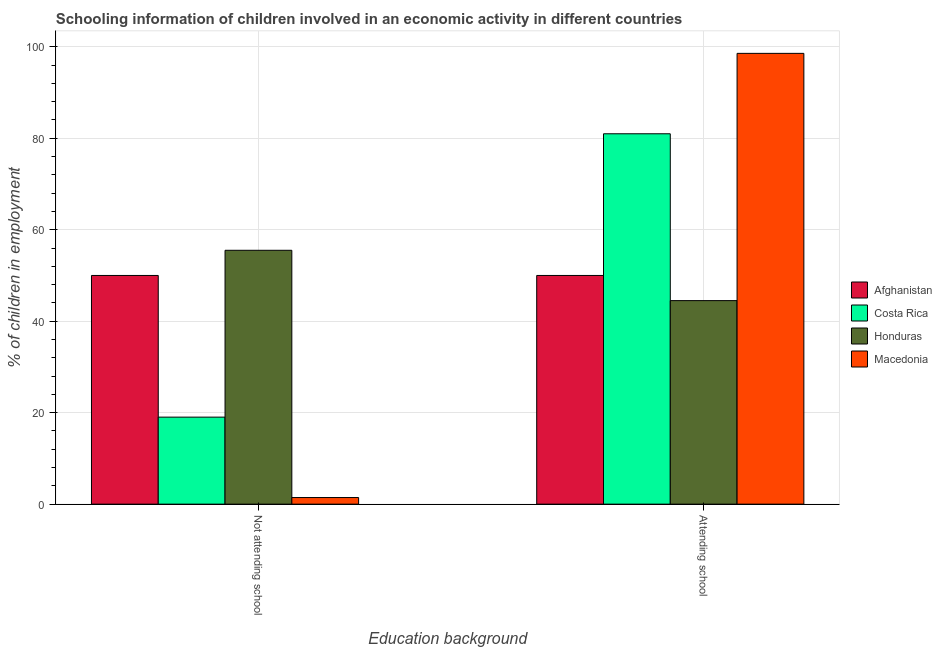How many groups of bars are there?
Ensure brevity in your answer.  2. Are the number of bars per tick equal to the number of legend labels?
Offer a very short reply. Yes. Are the number of bars on each tick of the X-axis equal?
Offer a terse response. Yes. How many bars are there on the 2nd tick from the left?
Provide a short and direct response. 4. What is the label of the 1st group of bars from the left?
Your answer should be very brief. Not attending school. What is the percentage of employed children who are attending school in Costa Rica?
Give a very brief answer. 80.98. Across all countries, what is the maximum percentage of employed children who are not attending school?
Make the answer very short. 55.5. Across all countries, what is the minimum percentage of employed children who are not attending school?
Provide a short and direct response. 1.45. In which country was the percentage of employed children who are not attending school maximum?
Your answer should be very brief. Honduras. In which country was the percentage of employed children who are attending school minimum?
Your answer should be compact. Honduras. What is the total percentage of employed children who are attending school in the graph?
Your answer should be compact. 274.03. What is the difference between the percentage of employed children who are attending school in Honduras and that in Macedonia?
Offer a very short reply. -54.05. What is the difference between the percentage of employed children who are not attending school in Macedonia and the percentage of employed children who are attending school in Costa Rica?
Ensure brevity in your answer.  -79.53. What is the average percentage of employed children who are not attending school per country?
Offer a terse response. 31.49. What is the difference between the percentage of employed children who are attending school and percentage of employed children who are not attending school in Macedonia?
Make the answer very short. 97.11. What is the ratio of the percentage of employed children who are not attending school in Honduras to that in Afghanistan?
Make the answer very short. 1.11. What does the 3rd bar from the left in Attending school represents?
Provide a succinct answer. Honduras. What does the 4th bar from the right in Not attending school represents?
Offer a terse response. Afghanistan. Are all the bars in the graph horizontal?
Make the answer very short. No. How many countries are there in the graph?
Your response must be concise. 4. Does the graph contain grids?
Provide a succinct answer. Yes. Where does the legend appear in the graph?
Your answer should be very brief. Center right. How are the legend labels stacked?
Your answer should be very brief. Vertical. What is the title of the graph?
Your answer should be compact. Schooling information of children involved in an economic activity in different countries. Does "Hong Kong" appear as one of the legend labels in the graph?
Provide a succinct answer. No. What is the label or title of the X-axis?
Provide a short and direct response. Education background. What is the label or title of the Y-axis?
Your answer should be very brief. % of children in employment. What is the % of children in employment of Afghanistan in Not attending school?
Offer a very short reply. 50. What is the % of children in employment of Costa Rica in Not attending school?
Give a very brief answer. 19.02. What is the % of children in employment in Honduras in Not attending school?
Keep it short and to the point. 55.5. What is the % of children in employment of Macedonia in Not attending school?
Your answer should be compact. 1.45. What is the % of children in employment of Afghanistan in Attending school?
Offer a very short reply. 50. What is the % of children in employment in Costa Rica in Attending school?
Provide a short and direct response. 80.98. What is the % of children in employment in Honduras in Attending school?
Offer a terse response. 44.5. What is the % of children in employment in Macedonia in Attending school?
Give a very brief answer. 98.55. Across all Education background, what is the maximum % of children in employment in Afghanistan?
Offer a very short reply. 50. Across all Education background, what is the maximum % of children in employment in Costa Rica?
Ensure brevity in your answer.  80.98. Across all Education background, what is the maximum % of children in employment of Honduras?
Provide a short and direct response. 55.5. Across all Education background, what is the maximum % of children in employment of Macedonia?
Provide a succinct answer. 98.55. Across all Education background, what is the minimum % of children in employment in Afghanistan?
Keep it short and to the point. 50. Across all Education background, what is the minimum % of children in employment in Costa Rica?
Offer a very short reply. 19.02. Across all Education background, what is the minimum % of children in employment in Honduras?
Provide a short and direct response. 44.5. Across all Education background, what is the minimum % of children in employment of Macedonia?
Your response must be concise. 1.45. What is the total % of children in employment in Costa Rica in the graph?
Offer a terse response. 100. What is the difference between the % of children in employment of Costa Rica in Not attending school and that in Attending school?
Keep it short and to the point. -61.95. What is the difference between the % of children in employment in Macedonia in Not attending school and that in Attending school?
Ensure brevity in your answer.  -97.11. What is the difference between the % of children in employment of Afghanistan in Not attending school and the % of children in employment of Costa Rica in Attending school?
Ensure brevity in your answer.  -30.98. What is the difference between the % of children in employment in Afghanistan in Not attending school and the % of children in employment in Honduras in Attending school?
Your answer should be compact. 5.5. What is the difference between the % of children in employment in Afghanistan in Not attending school and the % of children in employment in Macedonia in Attending school?
Provide a short and direct response. -48.55. What is the difference between the % of children in employment of Costa Rica in Not attending school and the % of children in employment of Honduras in Attending school?
Your answer should be very brief. -25.48. What is the difference between the % of children in employment of Costa Rica in Not attending school and the % of children in employment of Macedonia in Attending school?
Give a very brief answer. -79.53. What is the difference between the % of children in employment in Honduras in Not attending school and the % of children in employment in Macedonia in Attending school?
Offer a very short reply. -43.05. What is the average % of children in employment of Afghanistan per Education background?
Your answer should be compact. 50. What is the average % of children in employment in Costa Rica per Education background?
Ensure brevity in your answer.  50. What is the average % of children in employment in Honduras per Education background?
Provide a short and direct response. 50. What is the difference between the % of children in employment in Afghanistan and % of children in employment in Costa Rica in Not attending school?
Ensure brevity in your answer.  30.98. What is the difference between the % of children in employment of Afghanistan and % of children in employment of Honduras in Not attending school?
Ensure brevity in your answer.  -5.5. What is the difference between the % of children in employment in Afghanistan and % of children in employment in Macedonia in Not attending school?
Offer a very short reply. 48.55. What is the difference between the % of children in employment of Costa Rica and % of children in employment of Honduras in Not attending school?
Give a very brief answer. -36.48. What is the difference between the % of children in employment of Costa Rica and % of children in employment of Macedonia in Not attending school?
Keep it short and to the point. 17.58. What is the difference between the % of children in employment in Honduras and % of children in employment in Macedonia in Not attending school?
Provide a short and direct response. 54.05. What is the difference between the % of children in employment in Afghanistan and % of children in employment in Costa Rica in Attending school?
Your answer should be very brief. -30.98. What is the difference between the % of children in employment of Afghanistan and % of children in employment of Honduras in Attending school?
Your answer should be very brief. 5.5. What is the difference between the % of children in employment of Afghanistan and % of children in employment of Macedonia in Attending school?
Provide a succinct answer. -48.55. What is the difference between the % of children in employment of Costa Rica and % of children in employment of Honduras in Attending school?
Give a very brief answer. 36.48. What is the difference between the % of children in employment in Costa Rica and % of children in employment in Macedonia in Attending school?
Give a very brief answer. -17.58. What is the difference between the % of children in employment of Honduras and % of children in employment of Macedonia in Attending school?
Provide a short and direct response. -54.05. What is the ratio of the % of children in employment in Costa Rica in Not attending school to that in Attending school?
Your response must be concise. 0.23. What is the ratio of the % of children in employment of Honduras in Not attending school to that in Attending school?
Your answer should be very brief. 1.25. What is the ratio of the % of children in employment of Macedonia in Not attending school to that in Attending school?
Offer a terse response. 0.01. What is the difference between the highest and the second highest % of children in employment of Costa Rica?
Provide a short and direct response. 61.95. What is the difference between the highest and the second highest % of children in employment of Macedonia?
Ensure brevity in your answer.  97.11. What is the difference between the highest and the lowest % of children in employment of Afghanistan?
Your answer should be very brief. 0. What is the difference between the highest and the lowest % of children in employment of Costa Rica?
Your response must be concise. 61.95. What is the difference between the highest and the lowest % of children in employment of Honduras?
Make the answer very short. 11. What is the difference between the highest and the lowest % of children in employment in Macedonia?
Offer a very short reply. 97.11. 